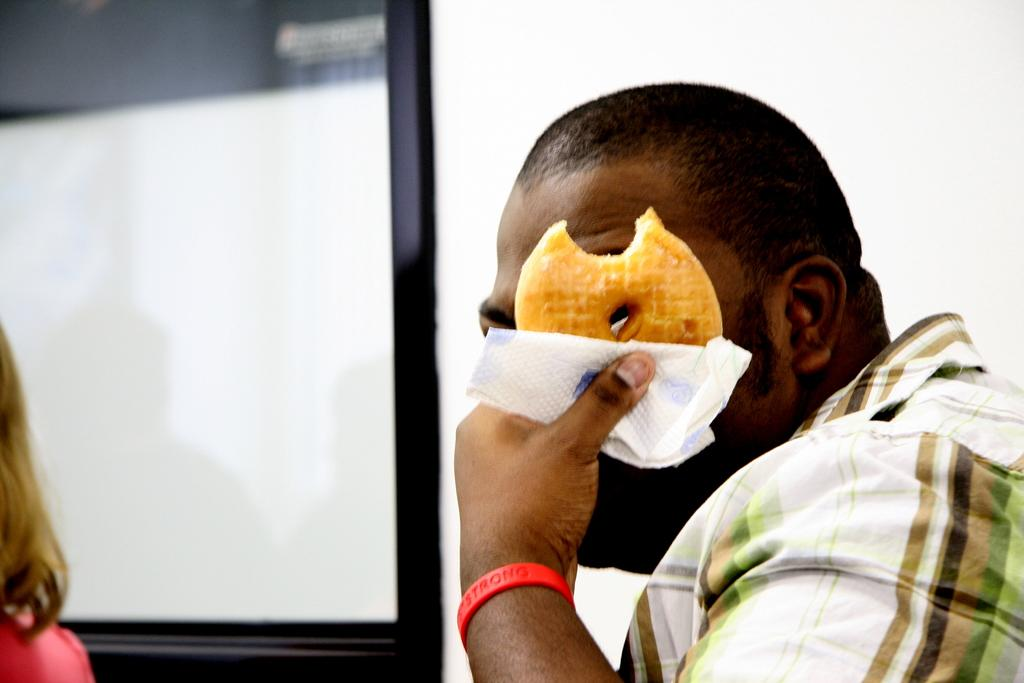Who is the main subject in the foreground of the picture? There is a man in the foreground of the picture. What is the man holding in his hands? The man is holding a doughnut and a tissue. Can you describe the person on the left side of the image? There is a person on the left side of the image, but their appearance or actions are not specified. What can be seen in the background of the image? There is a mirror in the background of the image, and the wall behind it is painted white. How many cars can be seen in the wilderness in the image? There are no cars or wilderness present in the image. What type of afterthought is depicted in the mirror in the image? There is no afterthought depicted in the mirror or anywhere else in the image. 